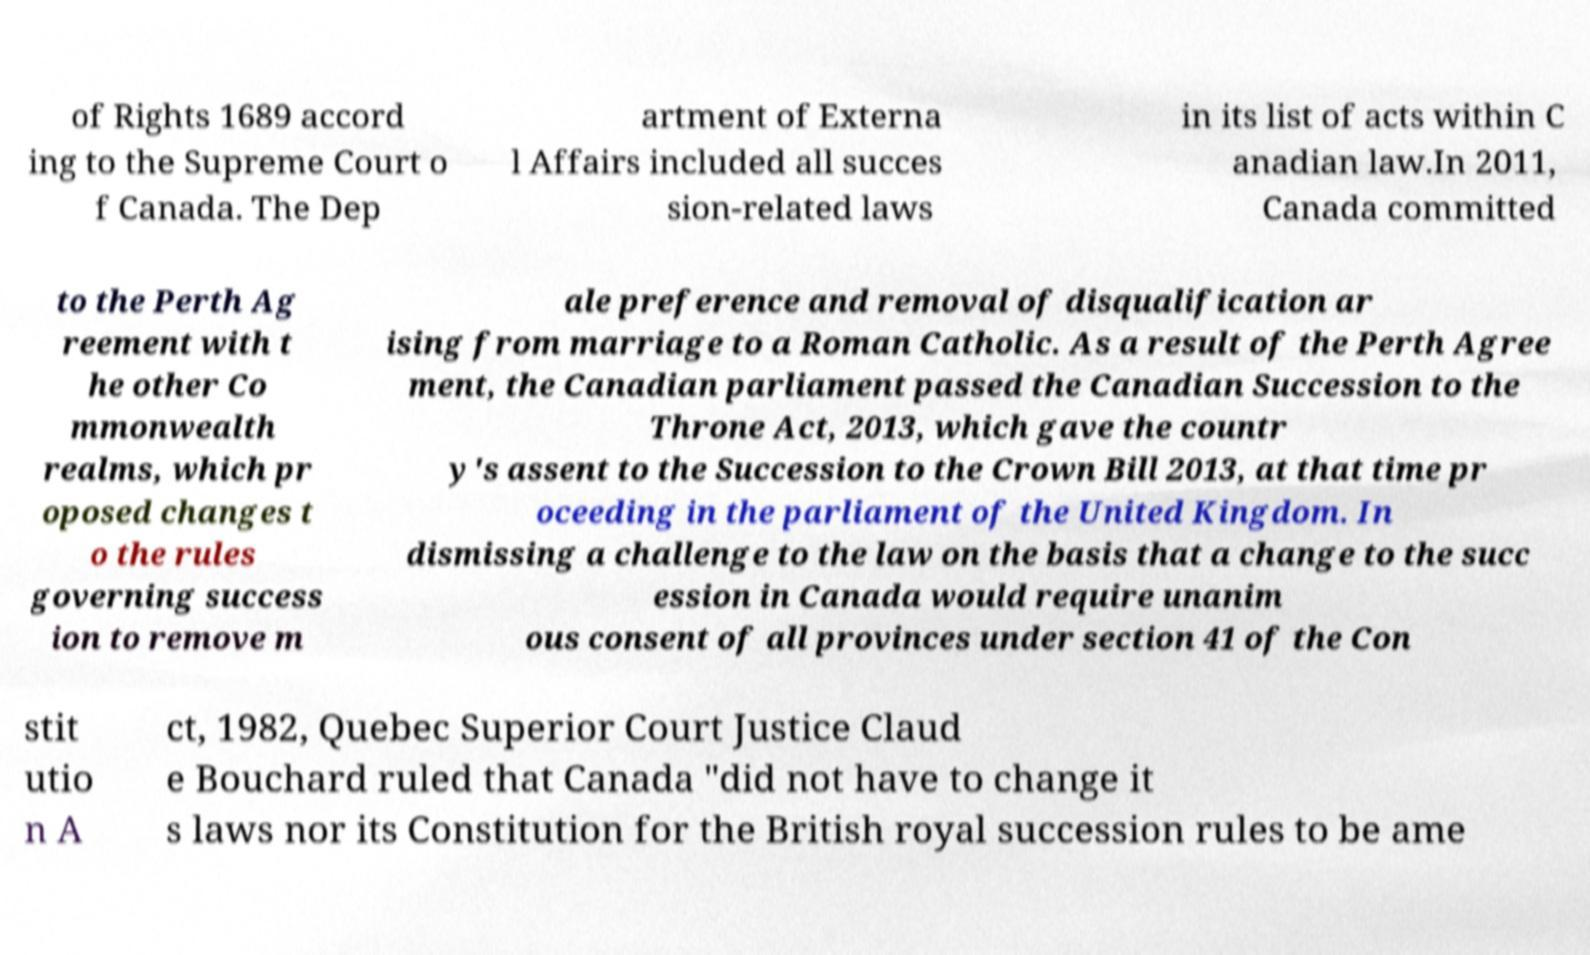Could you assist in decoding the text presented in this image and type it out clearly? of Rights 1689 accord ing to the Supreme Court o f Canada. The Dep artment of Externa l Affairs included all succes sion-related laws in its list of acts within C anadian law.In 2011, Canada committed to the Perth Ag reement with t he other Co mmonwealth realms, which pr oposed changes t o the rules governing success ion to remove m ale preference and removal of disqualification ar ising from marriage to a Roman Catholic. As a result of the Perth Agree ment, the Canadian parliament passed the Canadian Succession to the Throne Act, 2013, which gave the countr y's assent to the Succession to the Crown Bill 2013, at that time pr oceeding in the parliament of the United Kingdom. In dismissing a challenge to the law on the basis that a change to the succ ession in Canada would require unanim ous consent of all provinces under section 41 of the Con stit utio n A ct, 1982, Quebec Superior Court Justice Claud e Bouchard ruled that Canada "did not have to change it s laws nor its Constitution for the British royal succession rules to be ame 